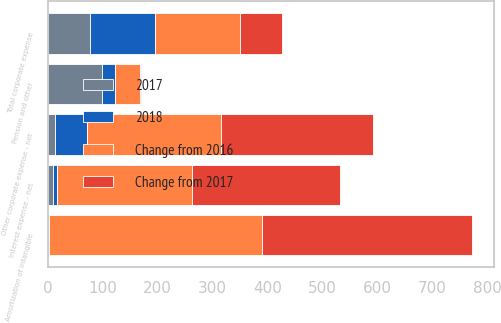<chart> <loc_0><loc_0><loc_500><loc_500><stacked_bar_chart><ecel><fcel>Amortization of intangible<fcel>Interest expense - net<fcel>Pension and other<fcel>Other corporate expense - net<fcel>Total corporate expense<nl><fcel>Change from 2017<fcel>382<fcel>271<fcel>1<fcel>277<fcel>77.5<nl><fcel>2017<fcel>2<fcel>10<fcel>98<fcel>14<fcel>77.5<nl><fcel>Change from 2016<fcel>388<fcel>246<fcel>45<fcel>244<fcel>154<nl><fcel>2018<fcel>1<fcel>6<fcel>25<fcel>57<fcel>118<nl></chart> 